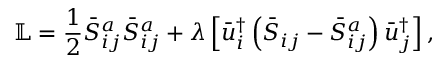Convert formula to latex. <formula><loc_0><loc_0><loc_500><loc_500>\mathbb { L } = \frac { 1 } { 2 } \bar { S } _ { i j } ^ { a } \bar { S } _ { i j } ^ { a } + \lambda \left [ { \bar { u } _ { i } ^ { \dag } \left ( { { { \bar { S } } _ { i j } } - \bar { S } _ { i j } ^ { a } } \right ) \bar { u } _ { j } ^ { \dag } } \right ] ,</formula> 